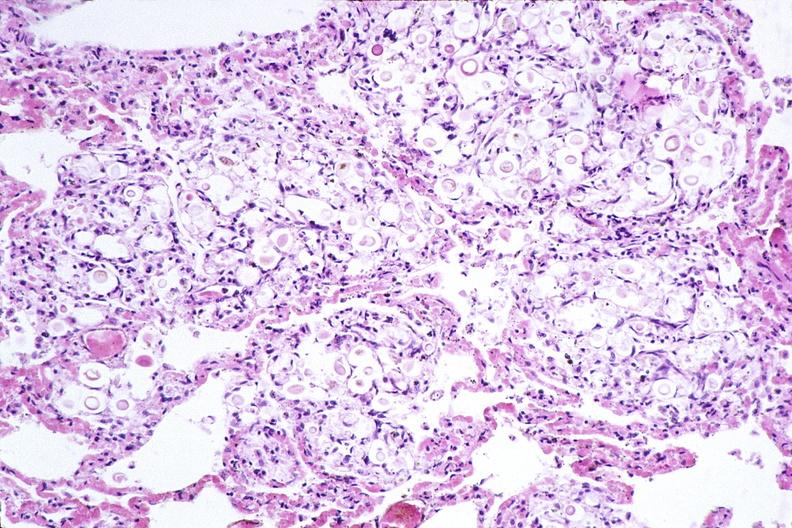s postpartum uterus present?
Answer the question using a single word or phrase. No 